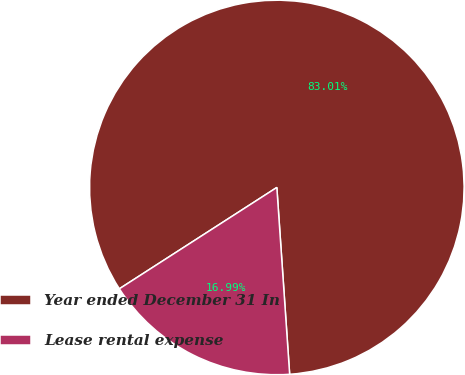<chart> <loc_0><loc_0><loc_500><loc_500><pie_chart><fcel>Year ended December 31 In<fcel>Lease rental expense<nl><fcel>83.01%<fcel>16.99%<nl></chart> 